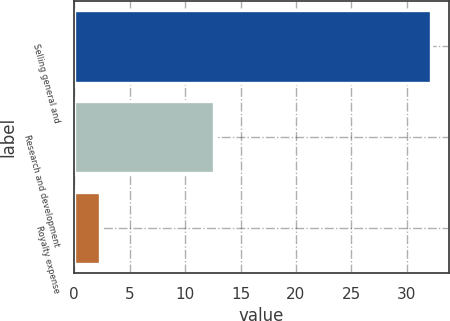<chart> <loc_0><loc_0><loc_500><loc_500><bar_chart><fcel>Selling general and<fcel>Research and development<fcel>Royalty expense<nl><fcel>32.2<fcel>12.6<fcel>2.3<nl></chart> 